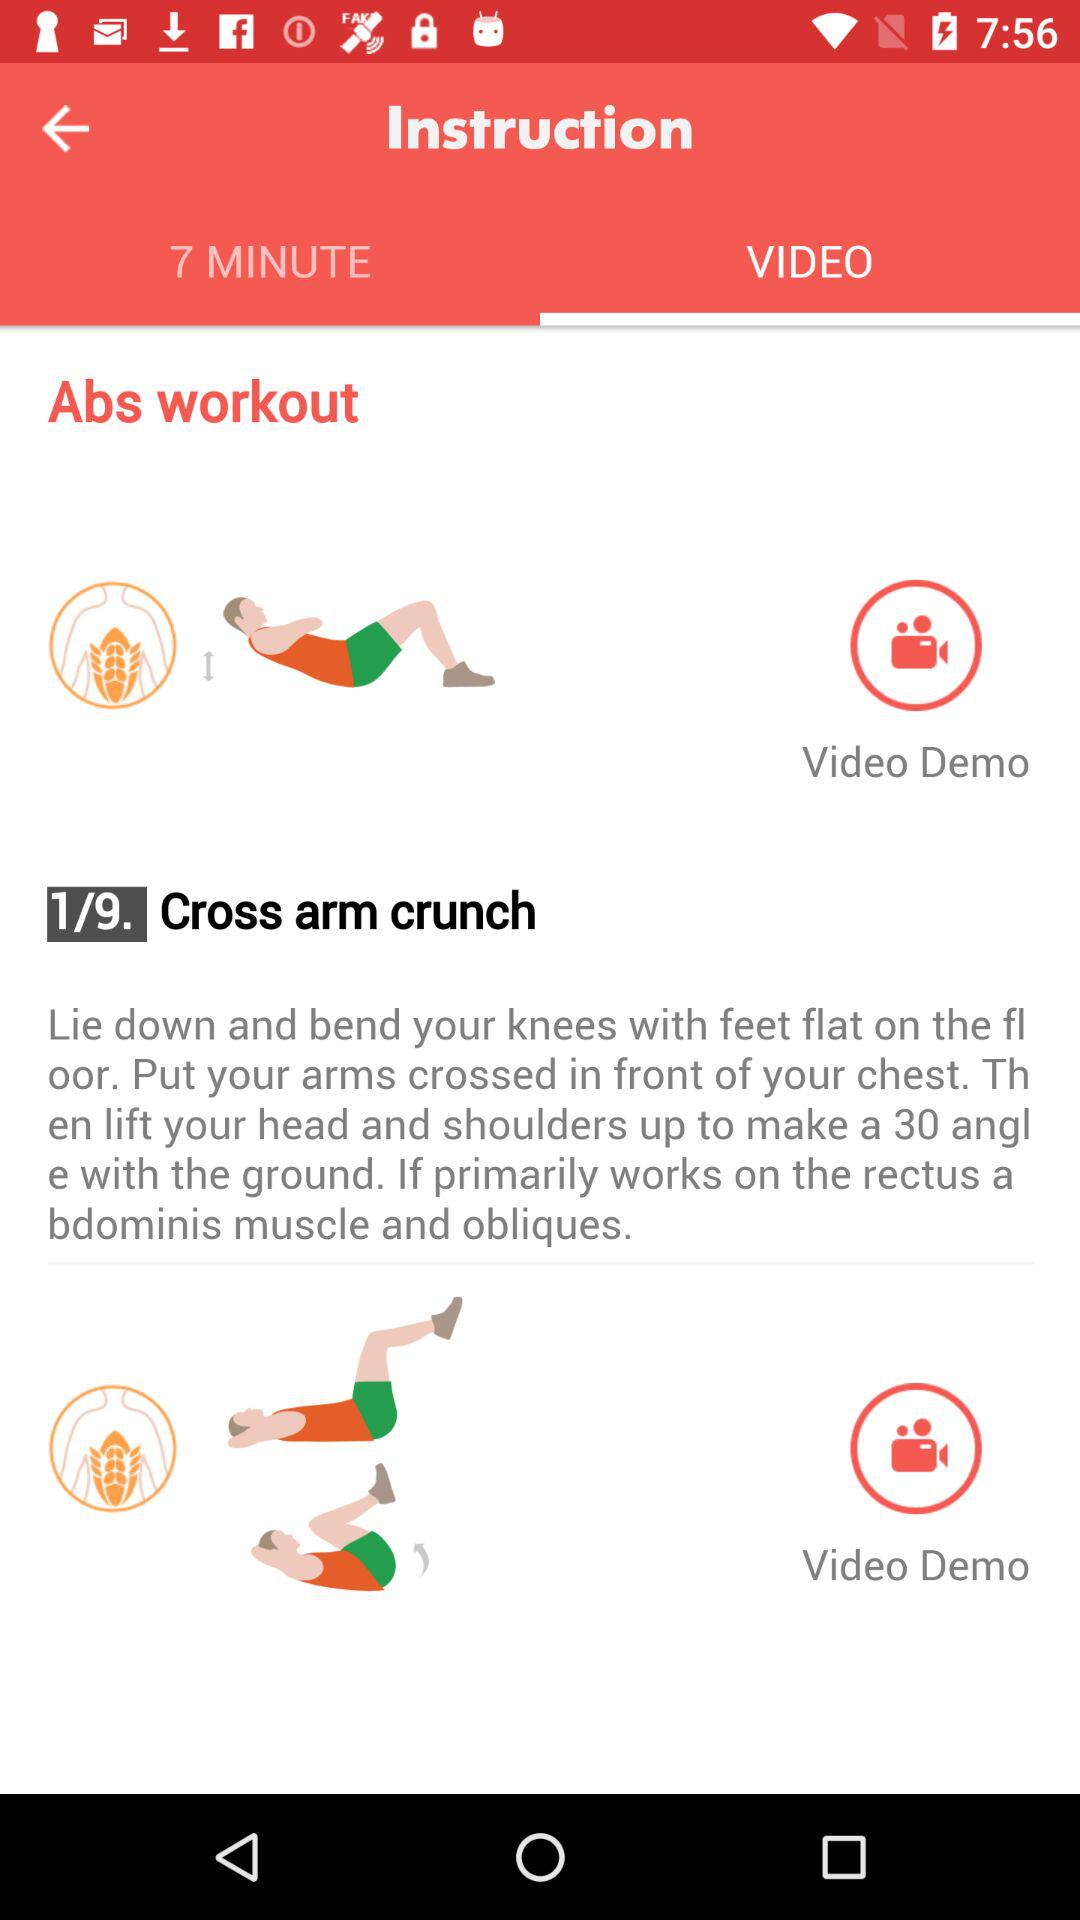What is the total count of exercises? The total count of exercises is 9. 